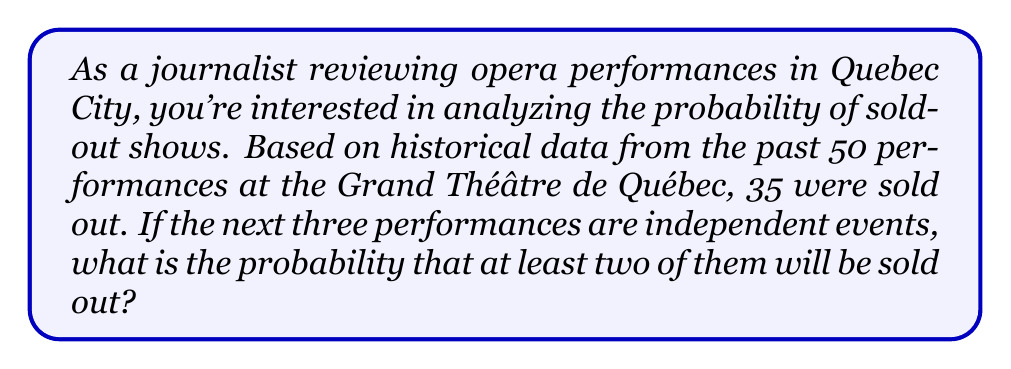Teach me how to tackle this problem. Let's approach this step-by-step:

1) First, we need to calculate the probability of a single show being sold out:
   $p = \frac{35}{50} = 0.7$

2) The probability of a show not being sold out is:
   $q = 1 - p = 1 - 0.7 = 0.3$

3) We want at least two out of three shows to be sold out. This can happen in three ways:
   - All three shows are sold out
   - First two are sold out, third isn't
   - First and third are sold out, second isn't
   - Second and third are sold out, first isn't

4) Let's calculate the probability of each scenario:
   - $P(\text{All three sold out}) = p^3 = 0.7^3 = 0.343$
   - $P(\text{First two sold out, third not}) = p^2q = 0.7^2 * 0.3 = 0.147$
   - $P(\text{First and third sold out, second not}) = p^2q = 0.7^2 * 0.3 = 0.147$
   - $P(\text{Second and third sold out, first not}) = p^2q = 0.7^2 * 0.3 = 0.147$

5) The total probability is the sum of these individual probabilities:

   $$P(\text{At least two sold out}) = 0.343 + 0.147 + 0.147 + 0.147 = 0.784$$

Thus, the probability that at least two of the next three performances will be sold out is 0.784 or 78.4%.
Answer: 0.784 